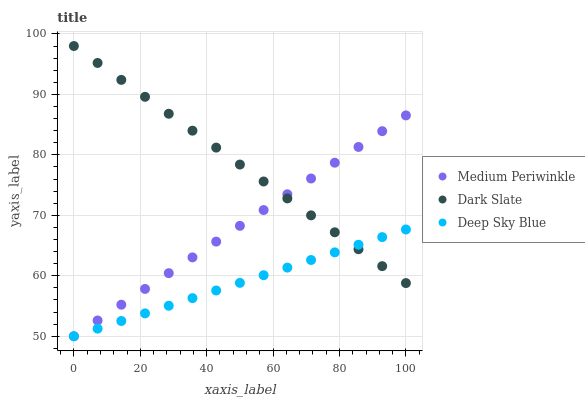Does Deep Sky Blue have the minimum area under the curve?
Answer yes or no. Yes. Does Dark Slate have the maximum area under the curve?
Answer yes or no. Yes. Does Medium Periwinkle have the minimum area under the curve?
Answer yes or no. No. Does Medium Periwinkle have the maximum area under the curve?
Answer yes or no. No. Is Deep Sky Blue the smoothest?
Answer yes or no. Yes. Is Medium Periwinkle the roughest?
Answer yes or no. Yes. Is Medium Periwinkle the smoothest?
Answer yes or no. No. Is Deep Sky Blue the roughest?
Answer yes or no. No. Does Medium Periwinkle have the lowest value?
Answer yes or no. Yes. Does Dark Slate have the highest value?
Answer yes or no. Yes. Does Medium Periwinkle have the highest value?
Answer yes or no. No. Does Deep Sky Blue intersect Medium Periwinkle?
Answer yes or no. Yes. Is Deep Sky Blue less than Medium Periwinkle?
Answer yes or no. No. Is Deep Sky Blue greater than Medium Periwinkle?
Answer yes or no. No. 